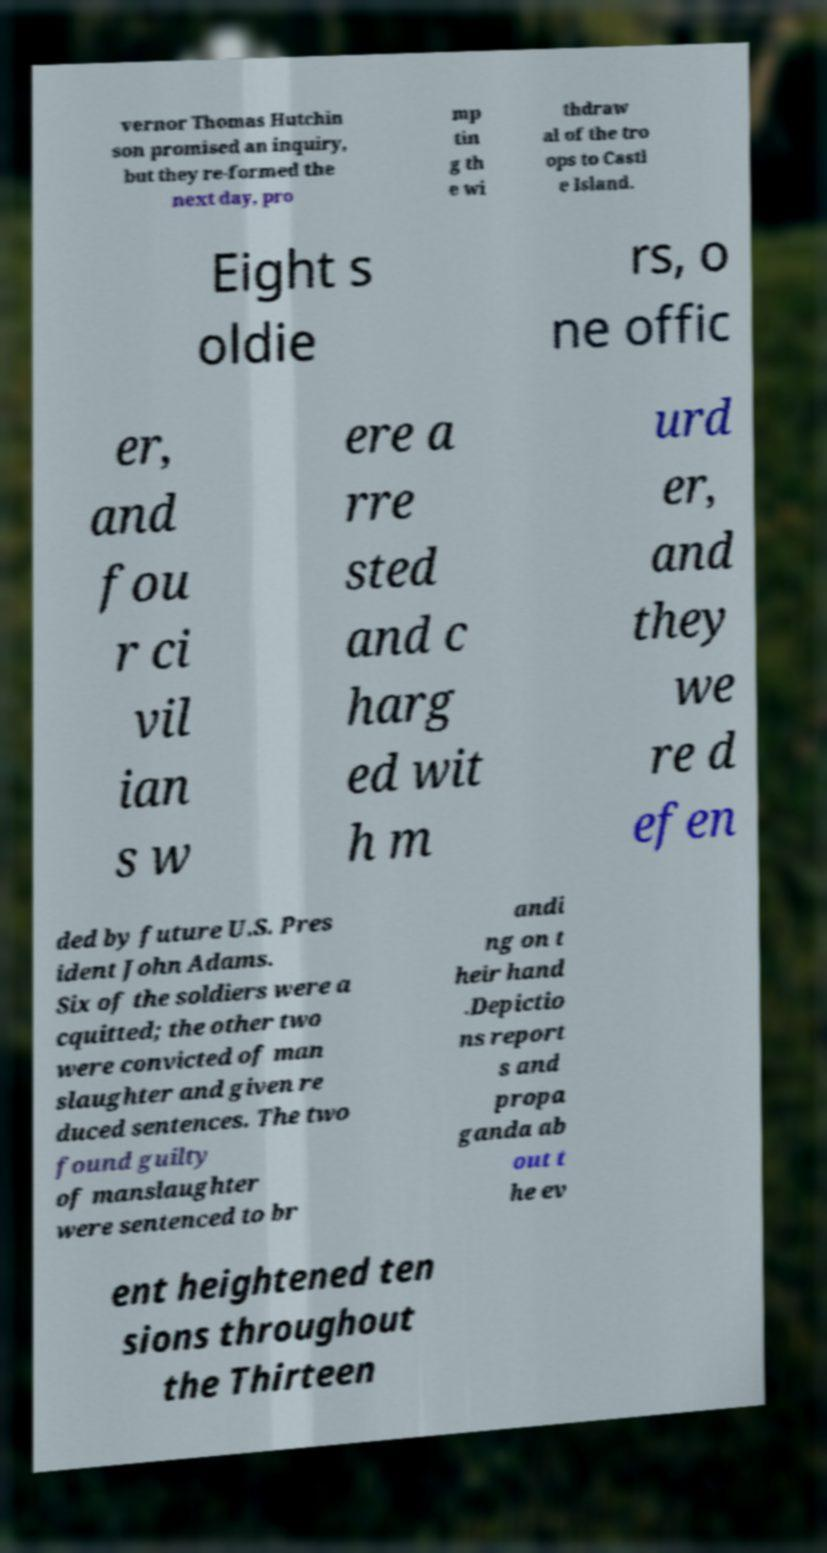Could you assist in decoding the text presented in this image and type it out clearly? vernor Thomas Hutchin son promised an inquiry, but they re-formed the next day, pro mp tin g th e wi thdraw al of the tro ops to Castl e Island. Eight s oldie rs, o ne offic er, and fou r ci vil ian s w ere a rre sted and c harg ed wit h m urd er, and they we re d efen ded by future U.S. Pres ident John Adams. Six of the soldiers were a cquitted; the other two were convicted of man slaughter and given re duced sentences. The two found guilty of manslaughter were sentenced to br andi ng on t heir hand .Depictio ns report s and propa ganda ab out t he ev ent heightened ten sions throughout the Thirteen 